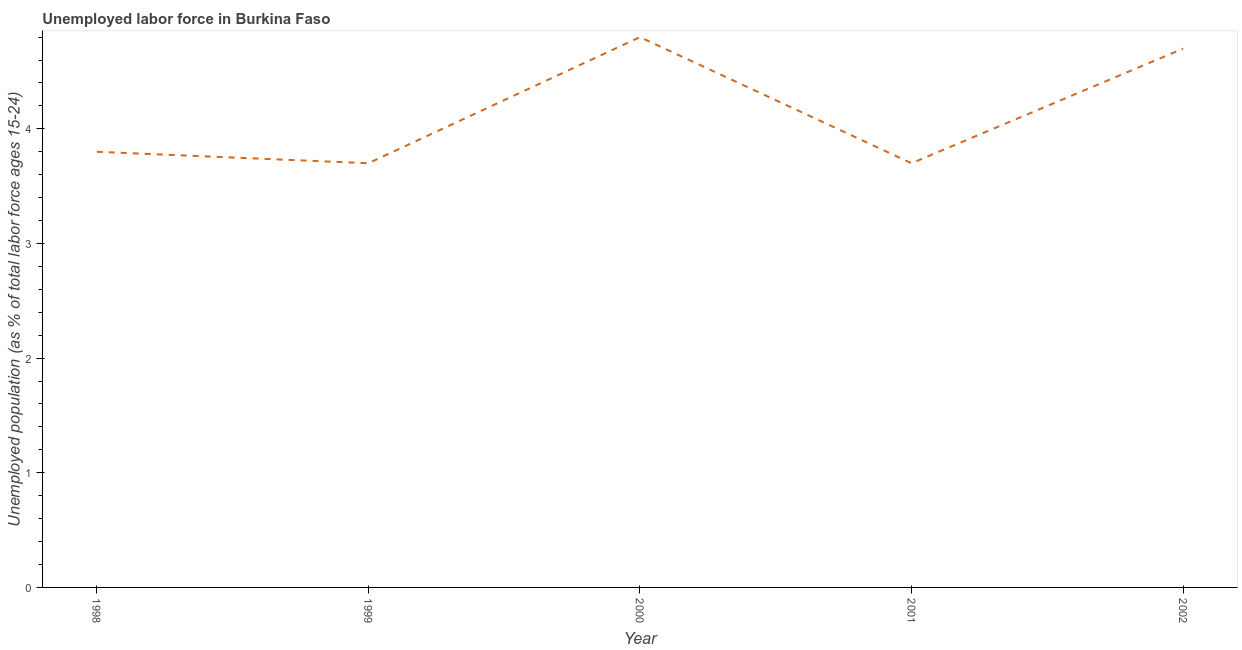What is the total unemployed youth population in 2002?
Your answer should be very brief. 4.7. Across all years, what is the maximum total unemployed youth population?
Make the answer very short. 4.8. Across all years, what is the minimum total unemployed youth population?
Your answer should be compact. 3.7. In which year was the total unemployed youth population maximum?
Your answer should be very brief. 2000. In which year was the total unemployed youth population minimum?
Provide a succinct answer. 1999. What is the sum of the total unemployed youth population?
Ensure brevity in your answer.  20.7. What is the difference between the total unemployed youth population in 1998 and 2000?
Offer a terse response. -1. What is the average total unemployed youth population per year?
Your answer should be compact. 4.14. What is the median total unemployed youth population?
Your answer should be very brief. 3.8. Do a majority of the years between 1999 and 2000 (inclusive) have total unemployed youth population greater than 1.6 %?
Keep it short and to the point. Yes. What is the ratio of the total unemployed youth population in 1998 to that in 2001?
Offer a terse response. 1.03. Is the total unemployed youth population in 2000 less than that in 2002?
Offer a very short reply. No. What is the difference between the highest and the second highest total unemployed youth population?
Keep it short and to the point. 0.1. Is the sum of the total unemployed youth population in 1998 and 2001 greater than the maximum total unemployed youth population across all years?
Offer a very short reply. Yes. What is the difference between the highest and the lowest total unemployed youth population?
Provide a succinct answer. 1.1. In how many years, is the total unemployed youth population greater than the average total unemployed youth population taken over all years?
Your answer should be very brief. 2. Does the total unemployed youth population monotonically increase over the years?
Make the answer very short. No. Does the graph contain any zero values?
Ensure brevity in your answer.  No. Does the graph contain grids?
Ensure brevity in your answer.  No. What is the title of the graph?
Offer a terse response. Unemployed labor force in Burkina Faso. What is the label or title of the Y-axis?
Provide a short and direct response. Unemployed population (as % of total labor force ages 15-24). What is the Unemployed population (as % of total labor force ages 15-24) in 1998?
Ensure brevity in your answer.  3.8. What is the Unemployed population (as % of total labor force ages 15-24) in 1999?
Give a very brief answer. 3.7. What is the Unemployed population (as % of total labor force ages 15-24) in 2000?
Make the answer very short. 4.8. What is the Unemployed population (as % of total labor force ages 15-24) in 2001?
Provide a short and direct response. 3.7. What is the Unemployed population (as % of total labor force ages 15-24) of 2002?
Provide a succinct answer. 4.7. What is the difference between the Unemployed population (as % of total labor force ages 15-24) in 1998 and 1999?
Your answer should be very brief. 0.1. What is the difference between the Unemployed population (as % of total labor force ages 15-24) in 1998 and 2000?
Your answer should be compact. -1. What is the difference between the Unemployed population (as % of total labor force ages 15-24) in 1999 and 2000?
Your response must be concise. -1.1. What is the difference between the Unemployed population (as % of total labor force ages 15-24) in 2000 and 2002?
Provide a succinct answer. 0.1. What is the ratio of the Unemployed population (as % of total labor force ages 15-24) in 1998 to that in 1999?
Offer a very short reply. 1.03. What is the ratio of the Unemployed population (as % of total labor force ages 15-24) in 1998 to that in 2000?
Make the answer very short. 0.79. What is the ratio of the Unemployed population (as % of total labor force ages 15-24) in 1998 to that in 2001?
Give a very brief answer. 1.03. What is the ratio of the Unemployed population (as % of total labor force ages 15-24) in 1998 to that in 2002?
Your response must be concise. 0.81. What is the ratio of the Unemployed population (as % of total labor force ages 15-24) in 1999 to that in 2000?
Ensure brevity in your answer.  0.77. What is the ratio of the Unemployed population (as % of total labor force ages 15-24) in 1999 to that in 2001?
Offer a terse response. 1. What is the ratio of the Unemployed population (as % of total labor force ages 15-24) in 1999 to that in 2002?
Offer a very short reply. 0.79. What is the ratio of the Unemployed population (as % of total labor force ages 15-24) in 2000 to that in 2001?
Provide a short and direct response. 1.3. What is the ratio of the Unemployed population (as % of total labor force ages 15-24) in 2001 to that in 2002?
Provide a succinct answer. 0.79. 